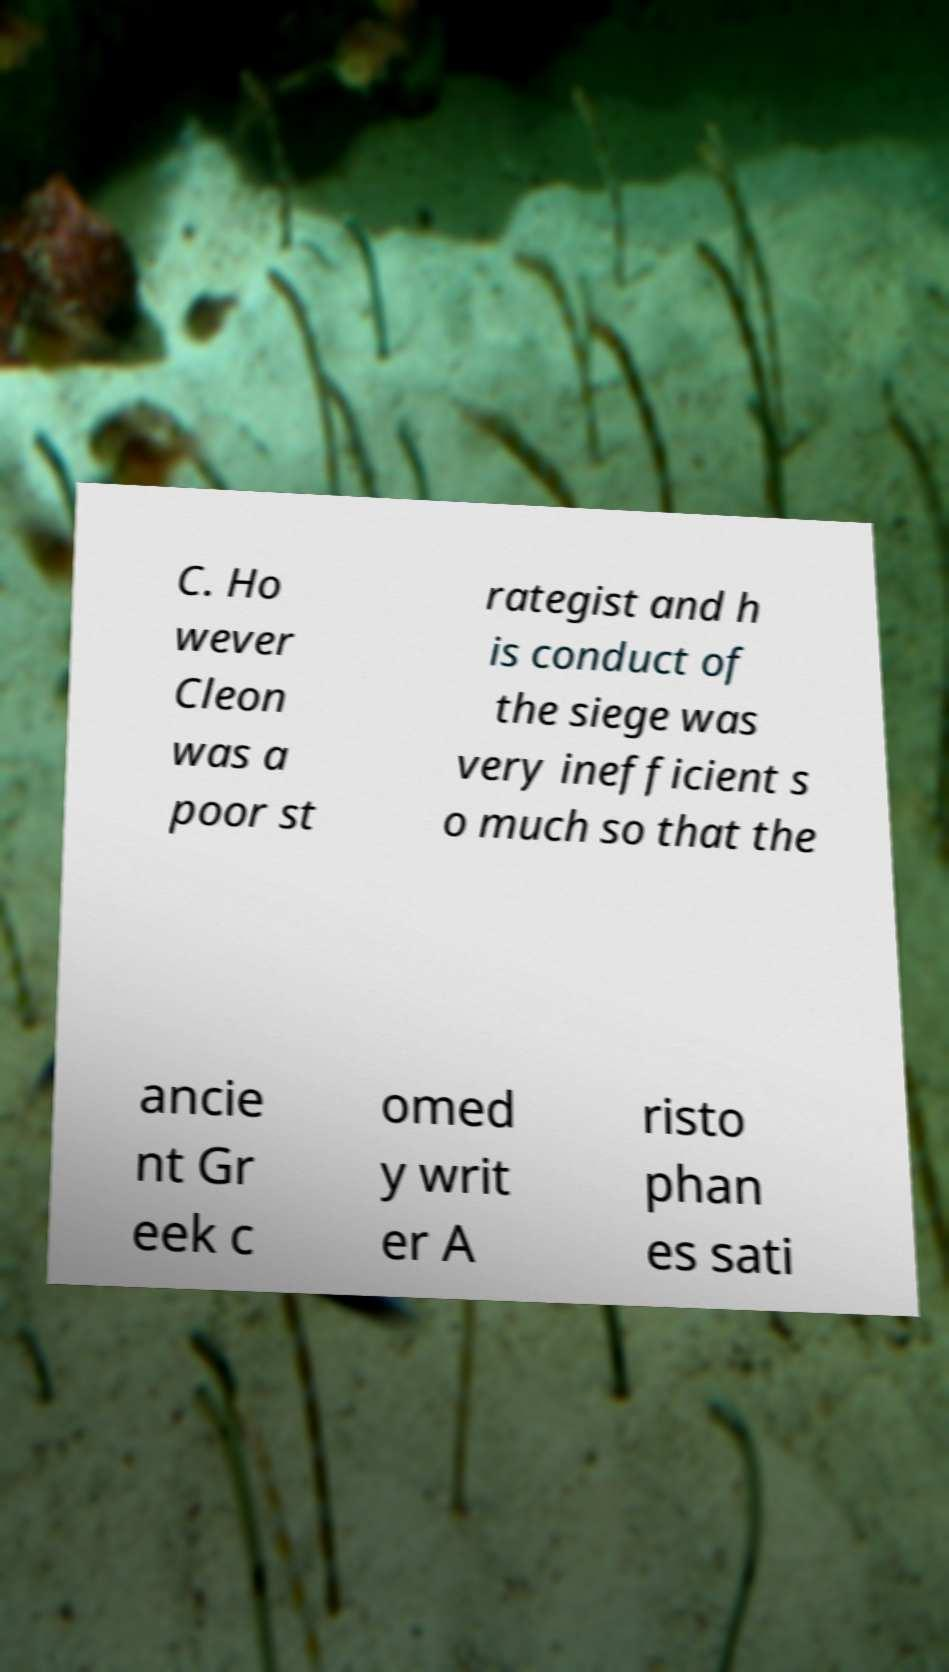Can you accurately transcribe the text from the provided image for me? C. Ho wever Cleon was a poor st rategist and h is conduct of the siege was very inefficient s o much so that the ancie nt Gr eek c omed y writ er A risto phan es sati 